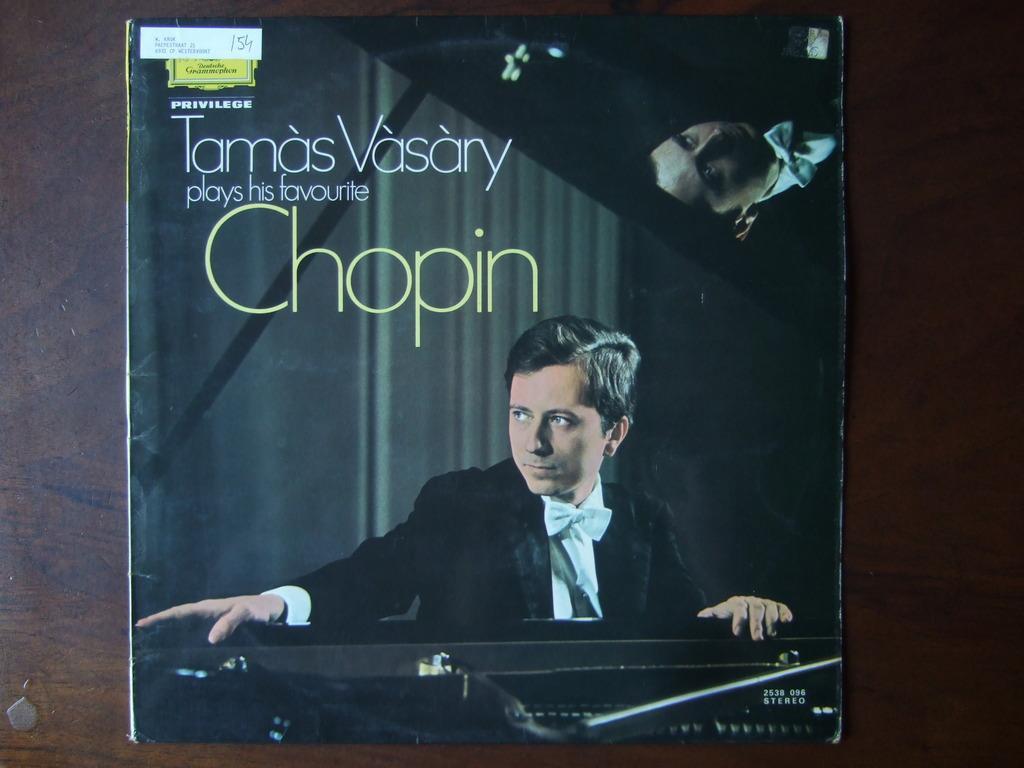Please provide a concise description of this image. Here in this picture we can see a poster present and on that poster we can see a person in a black colored coat on him over there and we can see some text present on it over there. 